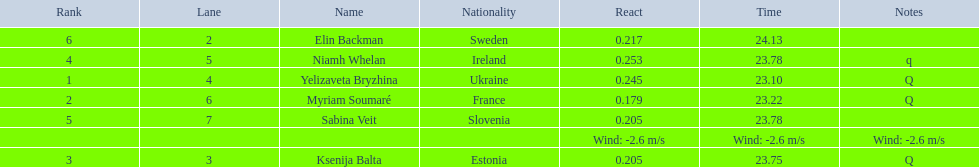What number of last names start with "b"? 3. 